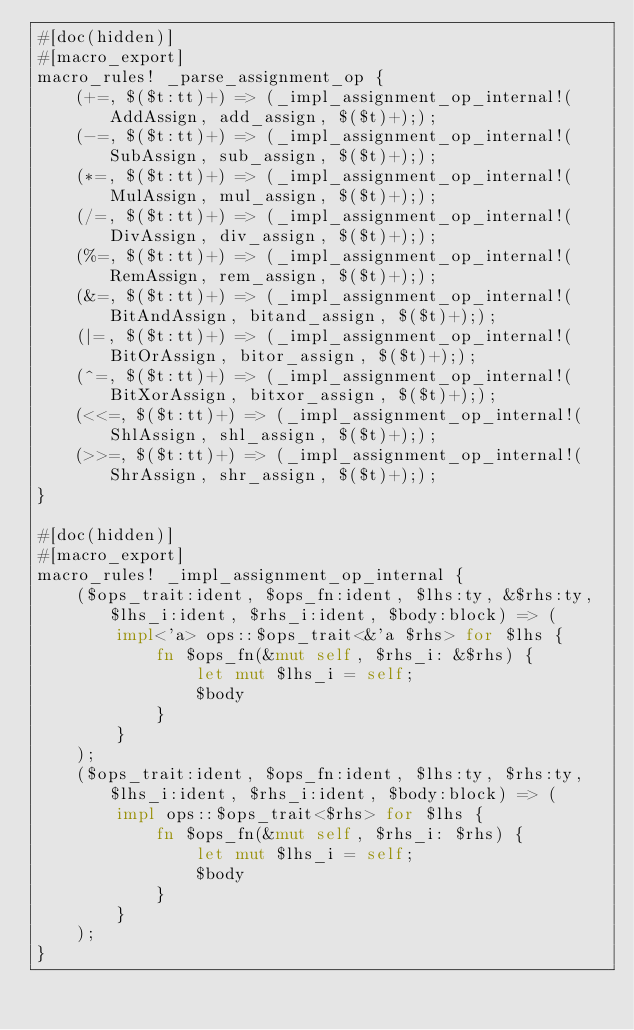Convert code to text. <code><loc_0><loc_0><loc_500><loc_500><_Rust_>#[doc(hidden)]
#[macro_export]
macro_rules! _parse_assignment_op {
    (+=, $($t:tt)+) => (_impl_assignment_op_internal!(AddAssign, add_assign, $($t)+););
    (-=, $($t:tt)+) => (_impl_assignment_op_internal!(SubAssign, sub_assign, $($t)+););
    (*=, $($t:tt)+) => (_impl_assignment_op_internal!(MulAssign, mul_assign, $($t)+););
    (/=, $($t:tt)+) => (_impl_assignment_op_internal!(DivAssign, div_assign, $($t)+););
    (%=, $($t:tt)+) => (_impl_assignment_op_internal!(RemAssign, rem_assign, $($t)+););
    (&=, $($t:tt)+) => (_impl_assignment_op_internal!(BitAndAssign, bitand_assign, $($t)+););
    (|=, $($t:tt)+) => (_impl_assignment_op_internal!(BitOrAssign, bitor_assign, $($t)+););
    (^=, $($t:tt)+) => (_impl_assignment_op_internal!(BitXorAssign, bitxor_assign, $($t)+););
    (<<=, $($t:tt)+) => (_impl_assignment_op_internal!(ShlAssign, shl_assign, $($t)+););
    (>>=, $($t:tt)+) => (_impl_assignment_op_internal!(ShrAssign, shr_assign, $($t)+););
}

#[doc(hidden)]
#[macro_export]
macro_rules! _impl_assignment_op_internal {
    ($ops_trait:ident, $ops_fn:ident, $lhs:ty, &$rhs:ty, $lhs_i:ident, $rhs_i:ident, $body:block) => (        
        impl<'a> ops::$ops_trait<&'a $rhs> for $lhs {
            fn $ops_fn(&mut self, $rhs_i: &$rhs) {
                let mut $lhs_i = self;
                $body
            }
        }
    );
    ($ops_trait:ident, $ops_fn:ident, $lhs:ty, $rhs:ty, $lhs_i:ident, $rhs_i:ident, $body:block) => (        
        impl ops::$ops_trait<$rhs> for $lhs {
            fn $ops_fn(&mut self, $rhs_i: $rhs) {
                let mut $lhs_i = self;
                $body
            }
        }
    );
}</code> 